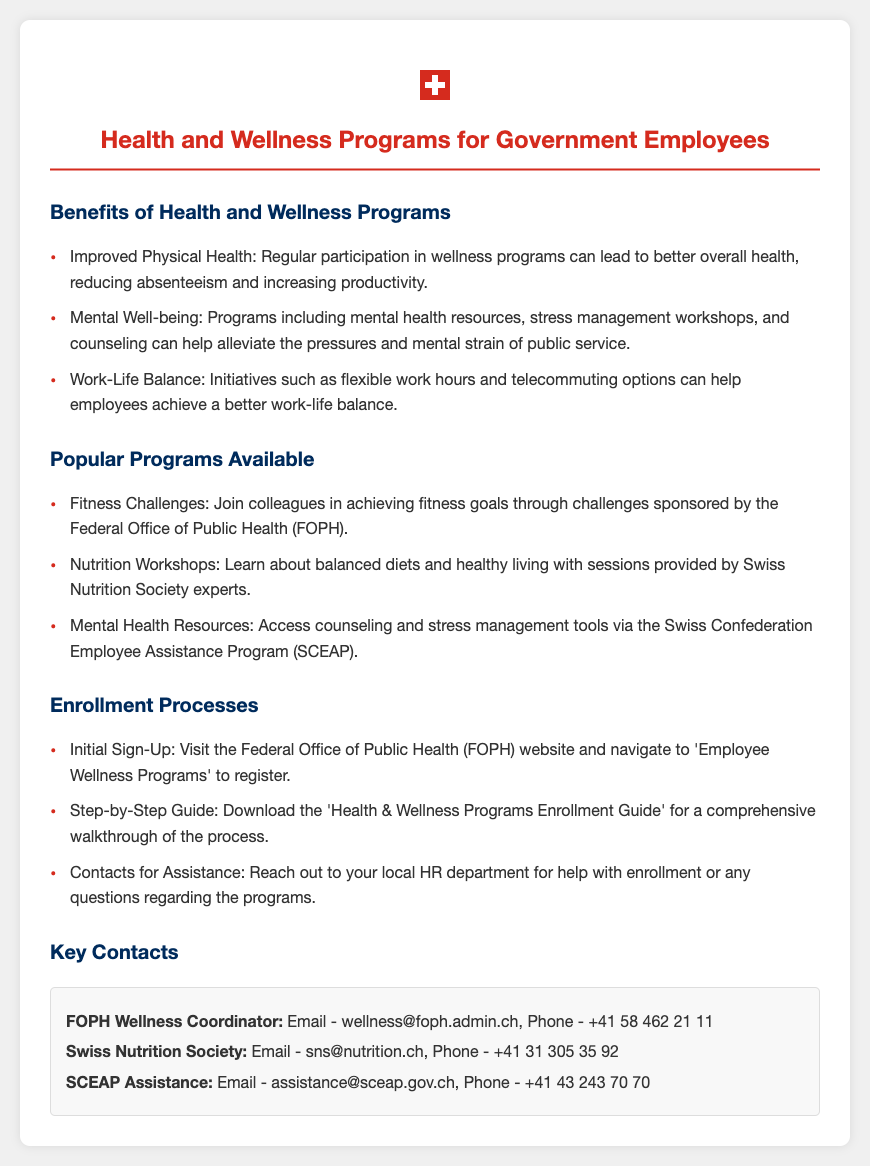What are the benefits of wellness programs? The document lists specific benefits of wellness programs such as improved physical health, mental well-being, and work-life balance.
Answer: Improved Physical Health, Mental Well-being, Work-Life Balance Which organization sponsors fitness challenges? The document states that fitness challenges are sponsored by the Federal Office of Public Health (FOPH).
Answer: Federal Office of Public Health (FOPH) What is the initial sign-up process? The document indicates that the initial sign-up involves visiting the FOPH website and navigating to 'Employee Wellness Programs' to register.
Answer: Visit the FOPH website Who can you contact for assistance with enrollment? The document mentions to reach out to your local HR department for help with enrollment.
Answer: Local HR department What is the contact email for the FOPH Wellness Coordinator? The document provides the email for the FOPH Wellness Coordinator as wellness@foph.admin.ch.
Answer: wellness@foph.admin.ch How can you access mental health resources? The document specifies access to counseling and stress management tools via the Swiss Confederation Employee Assistance Program (SCEAP).
Answer: Swiss Confederation Employee Assistance Program (SCEAP) What type of workshops does the Swiss Nutrition Society offer? The document notes that the Swiss Nutrition Society offers nutrition workshops.
Answer: Nutrition Workshops What is the phone number for SCEAP assistance? The document states the phone number for SCEAP assistance as +41 43 243 70 70.
Answer: +41 43 243 70 70 